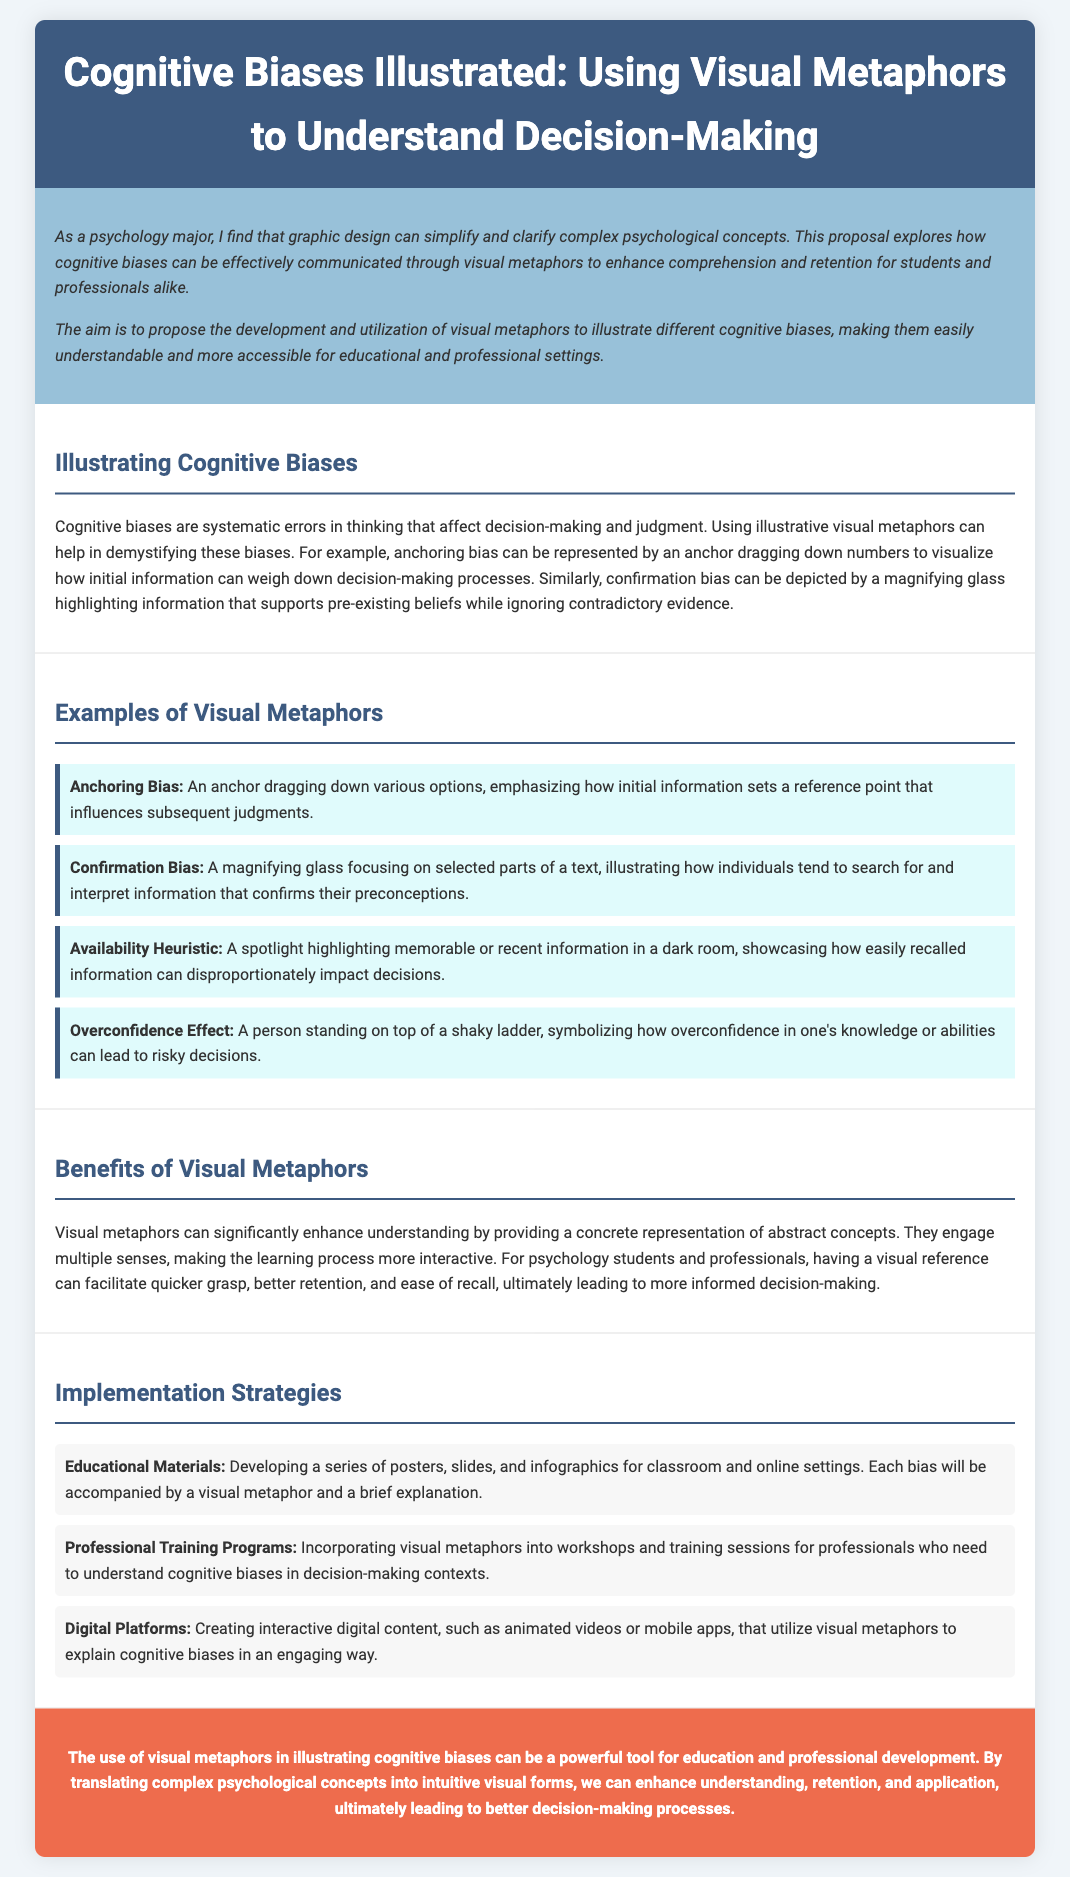what is the title of the proposal? The title of the proposal is the heading present in the document.
Answer: Cognitive Biases Illustrated: Using Visual Metaphors to Understand Decision-Making what is the primary aim of the proposal? The primary aim is outlined in the introduction section, focusing on the development of visual metaphors.
Answer: The development and utilization of visual metaphors how many examples of visual metaphors are provided? The document lists and describes a specific number of examples under the examples section.
Answer: Four what cognitive bias is represented by a spotlight? The specific cognitive biases illustrated by visual metaphors are mentioned in the examples section.
Answer: Availability Heuristic what color is used for the conclusion section? The background color of the conclusion section is specified in the style and is clearly depicted in the document.
Answer: #ee6c4d what is one implementation strategy mentioned for educational materials? The proposal lists multiple strategies for implementing visual metaphors in educational contexts.
Answer: Developing a series of posters what sensory engagement do visual metaphors provide according to the document? The benefits of visual metaphors discuss how they enhance understanding through engagement.
Answer: Multiple senses which cognitive bias is depicted by a magnifying glass? This is stated directly in the examples section, which specifies the visual metaphor associated with the bias.
Answer: Confirmation Bias what kind of digital content is suggested in the implementation strategies? The section on implementation strategies describes the types of digital content to be created.
Answer: Interactive digital content 